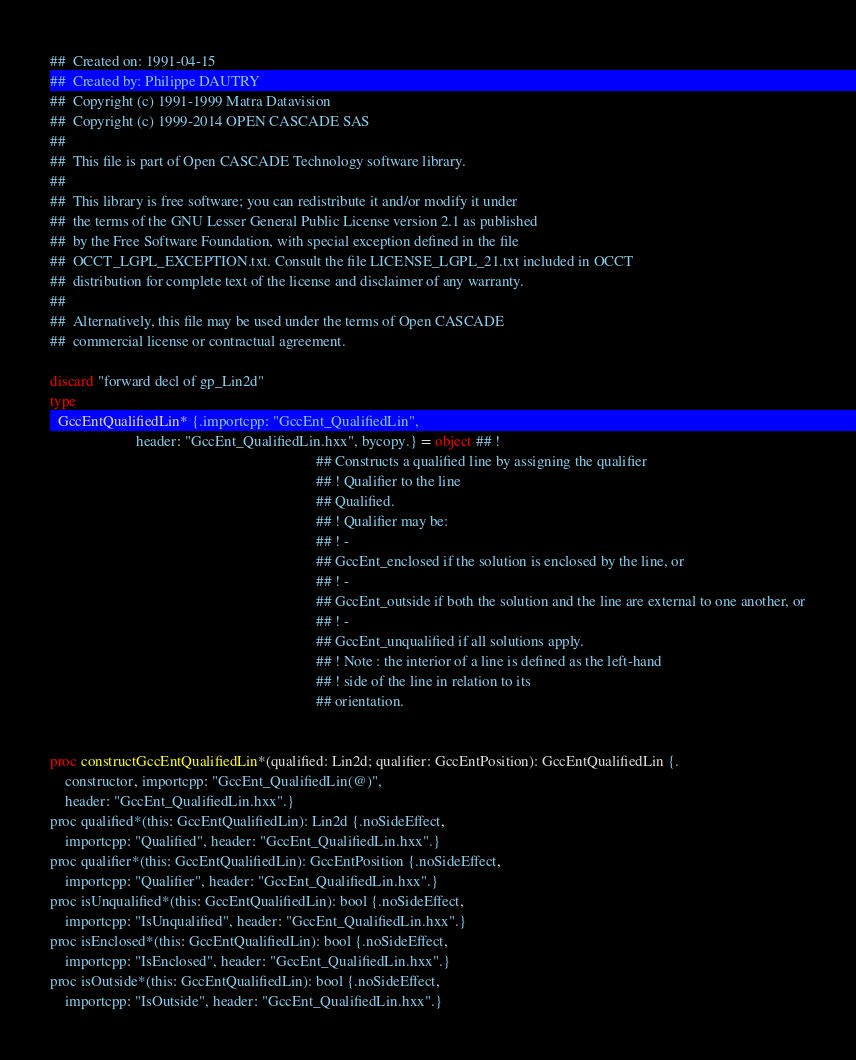Convert code to text. <code><loc_0><loc_0><loc_500><loc_500><_Nim_>##  Created on: 1991-04-15
##  Created by: Philippe DAUTRY
##  Copyright (c) 1991-1999 Matra Datavision
##  Copyright (c) 1999-2014 OPEN CASCADE SAS
##
##  This file is part of Open CASCADE Technology software library.
##
##  This library is free software; you can redistribute it and/or modify it under
##  the terms of the GNU Lesser General Public License version 2.1 as published
##  by the Free Software Foundation, with special exception defined in the file
##  OCCT_LGPL_EXCEPTION.txt. Consult the file LICENSE_LGPL_21.txt included in OCCT
##  distribution for complete text of the license and disclaimer of any warranty.
##
##  Alternatively, this file may be used under the terms of Open CASCADE
##  commercial license or contractual agreement.

discard "forward decl of gp_Lin2d"
type
  GccEntQualifiedLin* {.importcpp: "GccEnt_QualifiedLin",
                       header: "GccEnt_QualifiedLin.hxx", bycopy.} = object ## !
                                                                       ## Constructs a qualified line by assigning the qualifier
                                                                       ## ! Qualifier to the line
                                                                       ## Qualified.
                                                                       ## ! Qualifier may be:
                                                                       ## ! -
                                                                       ## GccEnt_enclosed if the solution is enclosed by the line, or
                                                                       ## ! -
                                                                       ## GccEnt_outside if both the solution and the line are external to one another, or
                                                                       ## ! -
                                                                       ## GccEnt_unqualified if all solutions apply.
                                                                       ## ! Note : the interior of a line is defined as the left-hand
                                                                       ## ! side of the line in relation to its
                                                                       ## orientation.


proc constructGccEntQualifiedLin*(qualified: Lin2d; qualifier: GccEntPosition): GccEntQualifiedLin {.
    constructor, importcpp: "GccEnt_QualifiedLin(@)",
    header: "GccEnt_QualifiedLin.hxx".}
proc qualified*(this: GccEntQualifiedLin): Lin2d {.noSideEffect,
    importcpp: "Qualified", header: "GccEnt_QualifiedLin.hxx".}
proc qualifier*(this: GccEntQualifiedLin): GccEntPosition {.noSideEffect,
    importcpp: "Qualifier", header: "GccEnt_QualifiedLin.hxx".}
proc isUnqualified*(this: GccEntQualifiedLin): bool {.noSideEffect,
    importcpp: "IsUnqualified", header: "GccEnt_QualifiedLin.hxx".}
proc isEnclosed*(this: GccEntQualifiedLin): bool {.noSideEffect,
    importcpp: "IsEnclosed", header: "GccEnt_QualifiedLin.hxx".}
proc isOutside*(this: GccEntQualifiedLin): bool {.noSideEffect,
    importcpp: "IsOutside", header: "GccEnt_QualifiedLin.hxx".}

























</code> 